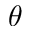<formula> <loc_0><loc_0><loc_500><loc_500>\theta</formula> 